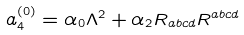Convert formula to latex. <formula><loc_0><loc_0><loc_500><loc_500>a ^ { ( 0 ) } _ { 4 } = \alpha _ { 0 } \Lambda ^ { 2 } + \alpha _ { 2 } R _ { a b c d } R ^ { a b c d }</formula> 